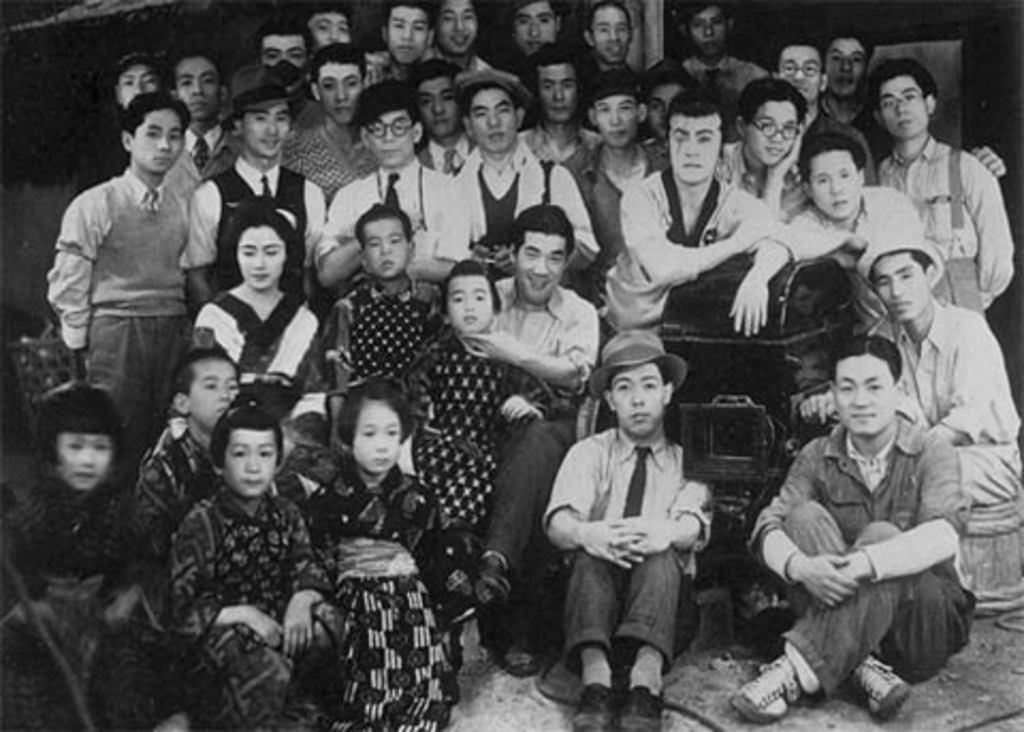Could you give a brief overview of what you see in this image? In this image there are persons sitting and standing. In the center there is an object which is black in colour. 